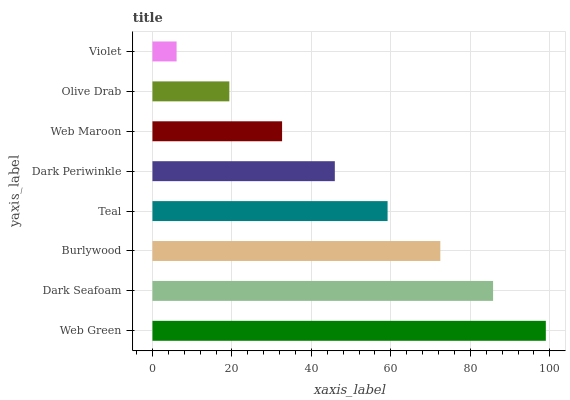Is Violet the minimum?
Answer yes or no. Yes. Is Web Green the maximum?
Answer yes or no. Yes. Is Dark Seafoam the minimum?
Answer yes or no. No. Is Dark Seafoam the maximum?
Answer yes or no. No. Is Web Green greater than Dark Seafoam?
Answer yes or no. Yes. Is Dark Seafoam less than Web Green?
Answer yes or no. Yes. Is Dark Seafoam greater than Web Green?
Answer yes or no. No. Is Web Green less than Dark Seafoam?
Answer yes or no. No. Is Teal the high median?
Answer yes or no. Yes. Is Dark Periwinkle the low median?
Answer yes or no. Yes. Is Violet the high median?
Answer yes or no. No. Is Olive Drab the low median?
Answer yes or no. No. 